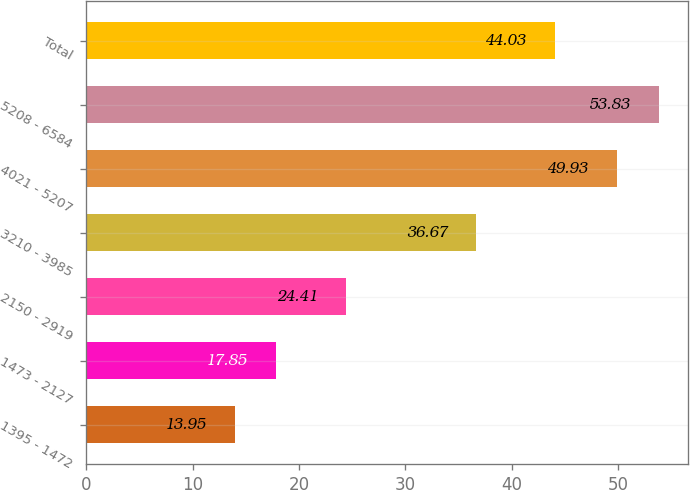Convert chart to OTSL. <chart><loc_0><loc_0><loc_500><loc_500><bar_chart><fcel>1395 - 1472<fcel>1473 - 2127<fcel>2150 - 2919<fcel>3210 - 3985<fcel>4021 - 5207<fcel>5208 - 6584<fcel>Total<nl><fcel>13.95<fcel>17.85<fcel>24.41<fcel>36.67<fcel>49.93<fcel>53.83<fcel>44.03<nl></chart> 